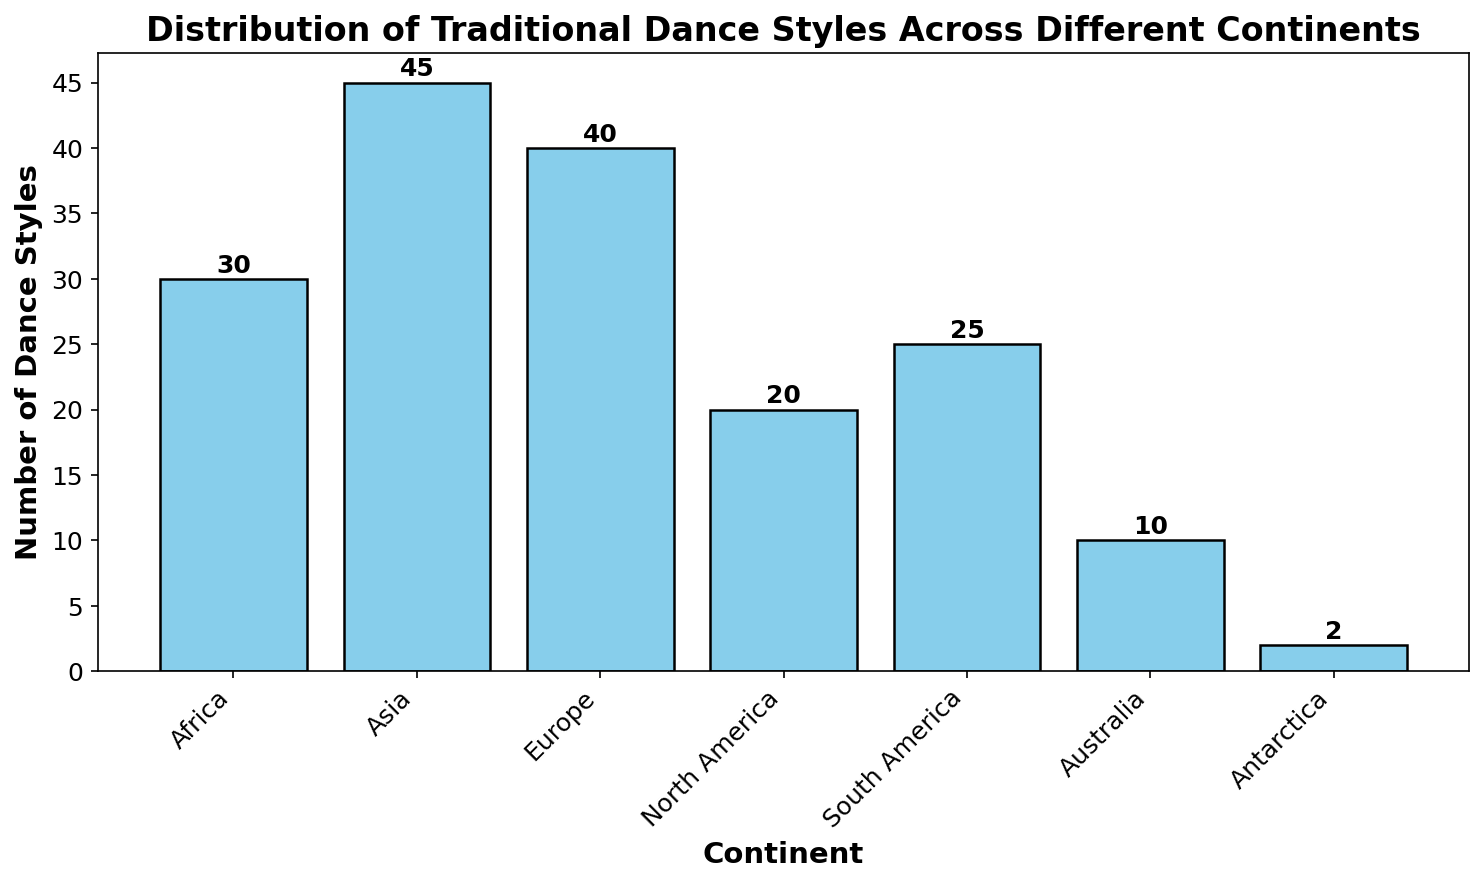Which continent has the highest number of traditional dance styles? By looking at the height of the bars, Asia has the tallest bar, indicating it has the highest number of traditional dance styles.
Answer: Asia How many continents have fewer than 20 traditional dance styles? By checking the bars that represent numbers less than 20, only Australia and Antarctica fall into this category.
Answer: 2 What's the difference in the number of dance styles between Europe and North America? Europe has 40 traditional dance styles, and North America has 20. Subtracting them gives 40 - 20 = 20.
Answer: 20 What is the total number of traditional dance styles across all continents? Summing up the dance style counts: 30 (Africa) + 45 (Asia) + 40 (Europe) + 20 (North America) + 25 (South America) + 10 (Australia) + 2 (Antarctica) = 172.
Answer: 172 Which continents have more than 30 traditional dance styles? The continents with bars exceeding the height of 30 are Africa, Asia, and Europe.
Answer: Africa, Asia, Europe What's the average number of dance styles per continent? Sum the total number of dance styles (172) and divide by the number of continents (7): 172 / 7 ≈ 24.57
Answer: 24.57 How much taller is the bar for Asia compared to the bar for Antarctica? The bar for Asia has a height of 45, and for Antarctica, it is 2. The difference is 45 - 2 = 43.
Answer: 43 Which continent has the shortest bar, and what is its height? Antarctica has the shortest bar with a height of 2.
Answer: Antarctica, 2 